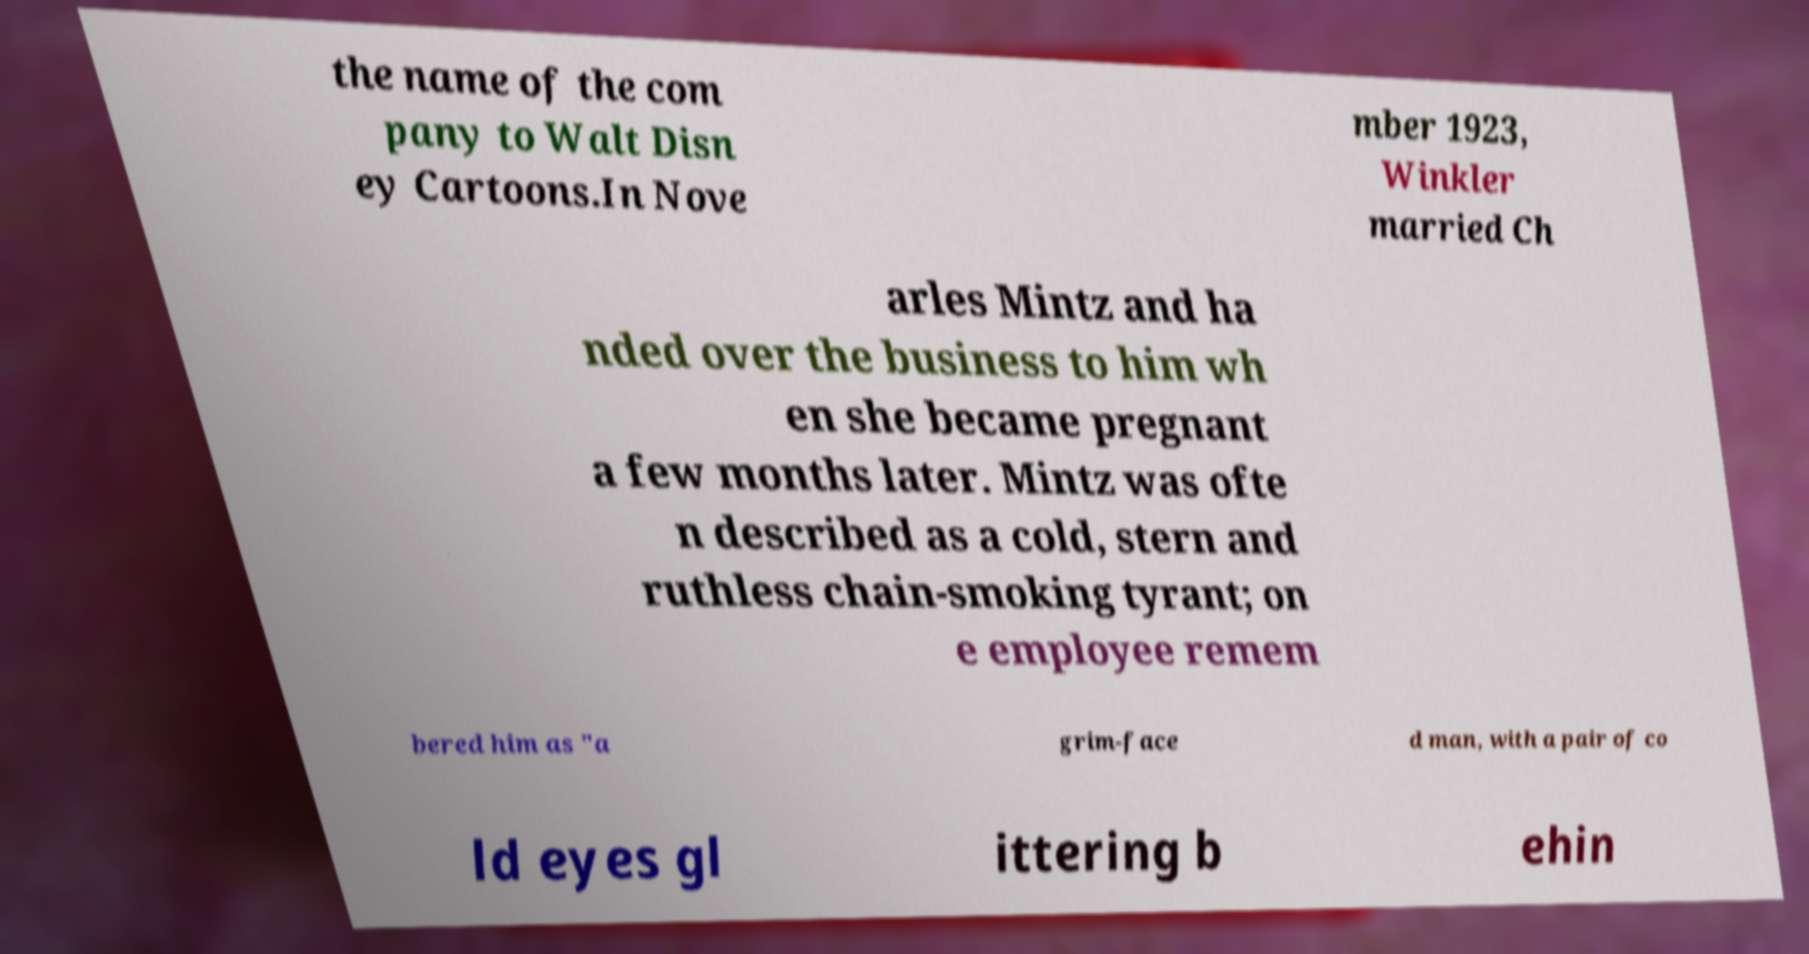There's text embedded in this image that I need extracted. Can you transcribe it verbatim? the name of the com pany to Walt Disn ey Cartoons.In Nove mber 1923, Winkler married Ch arles Mintz and ha nded over the business to him wh en she became pregnant a few months later. Mintz was ofte n described as a cold, stern and ruthless chain-smoking tyrant; on e employee remem bered him as "a grim-face d man, with a pair of co ld eyes gl ittering b ehin 